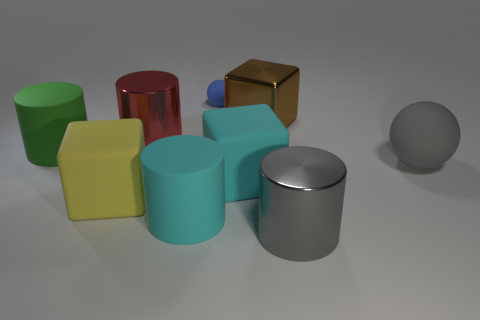Is there any other thing of the same color as the small sphere?
Your response must be concise. No. Does the red thing have the same shape as the big cyan rubber object to the right of the blue thing?
Offer a terse response. No. What color is the large metal cylinder behind the large rubber block that is left of the large cyan matte object that is in front of the large yellow cube?
Offer a very short reply. Red. Are there any other things that are made of the same material as the large green thing?
Provide a short and direct response. Yes. There is a big cyan object left of the small ball; is its shape the same as the big red object?
Give a very brief answer. Yes. What is the material of the large sphere?
Give a very brief answer. Rubber. There is a rubber object behind the rubber cylinder that is behind the big cyan thing that is to the left of the blue matte thing; what shape is it?
Provide a succinct answer. Sphere. How many other objects are there of the same shape as the red shiny thing?
Your response must be concise. 3. There is a big sphere; is its color the same as the metal thing right of the brown metallic object?
Give a very brief answer. Yes. How many cyan cylinders are there?
Ensure brevity in your answer.  1. 